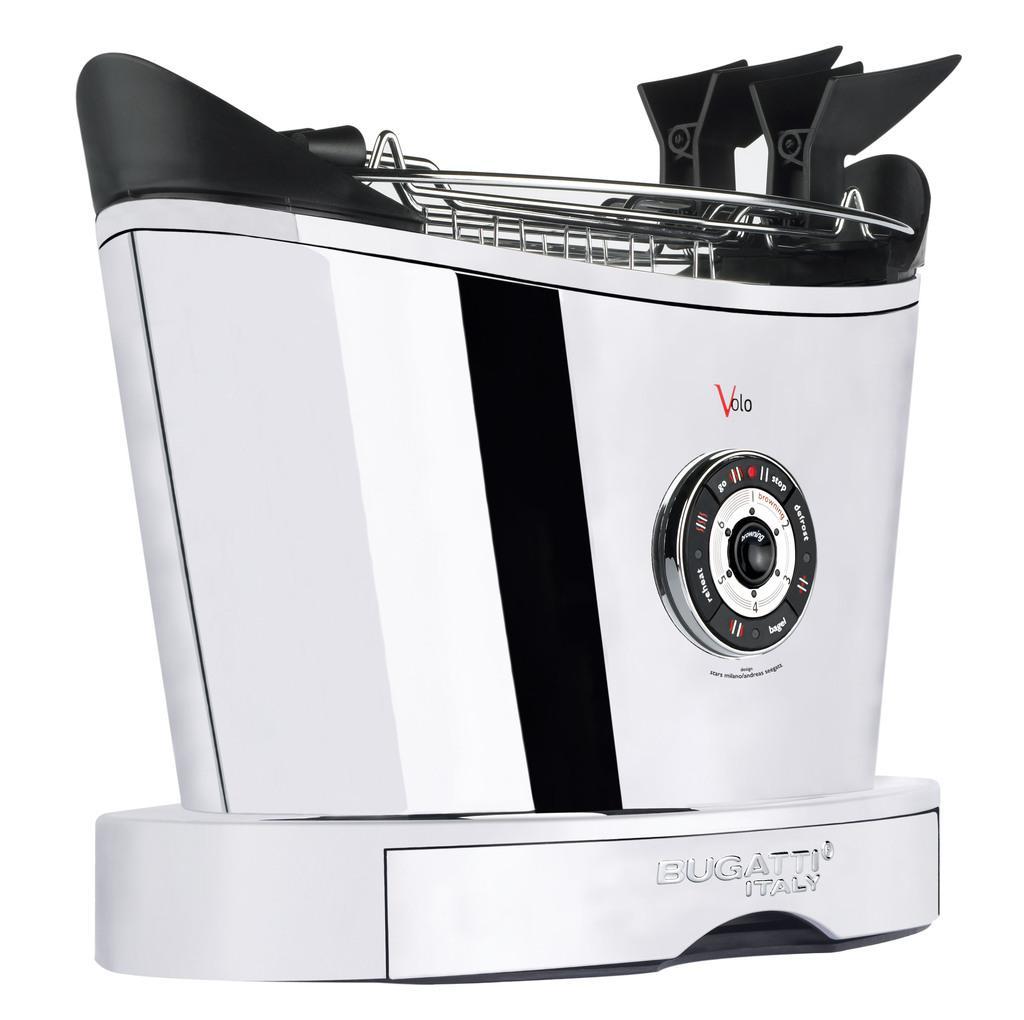How would you summarize this image in a sentence or two? In this picture there is a Bugatti toaster in the center of the image. 